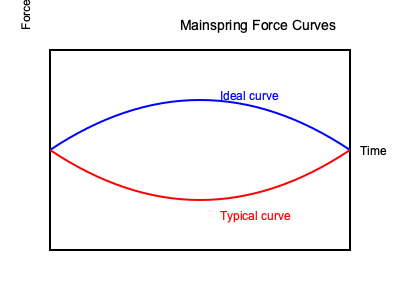In designing a mainspring for a clock with an extended power reserve, which characteristic of the force curve is most crucial for maintaining consistent timekeeping throughout the entire wind-down period, and how does this relate to the graph shown? To answer this question, we need to consider the following steps:

1. Understand the importance of consistent force delivery in horology:
   - Consistent force ensures uniform amplitude of the balance wheel oscillations.
   - Uniform amplitude leads to more accurate timekeeping.

2. Analyze the graph:
   - The blue curve represents an ideal mainspring force curve.
   - The red curve represents a typical mainspring force curve.

3. Compare the characteristics of both curves:
   - The ideal curve (blue) is relatively flat, indicating a more consistent force output over time.
   - The typical curve (red) shows a steep initial decline followed by a gradual decrease in force.

4. Consider the impact on timekeeping:
   - The ideal curve would provide a more consistent force throughout the power reserve period.
   - The typical curve would cause variations in balance wheel amplitude as the mainspring unwinds.

5. Relate to long power reserve requirements:
   - For extended power reserves, maintaining consistency becomes even more critical.
   - The longer the desired power reserve, the more important it is to achieve a flatter force curve.

6. Identify the key characteristic:
   - The most crucial characteristic is the flatness or linearity of the force curve.
   - A flatter curve ensures more consistent force delivery throughout the entire wind-down period.

7. Consider mainspring design implications:
   - Achieving a flatter curve often involves using longer, thinner mainsprings.
   - Material selection and heat treatment also play roles in optimizing the force curve.

Therefore, the most crucial characteristic for maintaining consistent timekeeping in a clock with an extended power reserve is the flatness of the mainspring force curve, as illustrated by the blue line in the graph.
Answer: Flatness of the force curve 